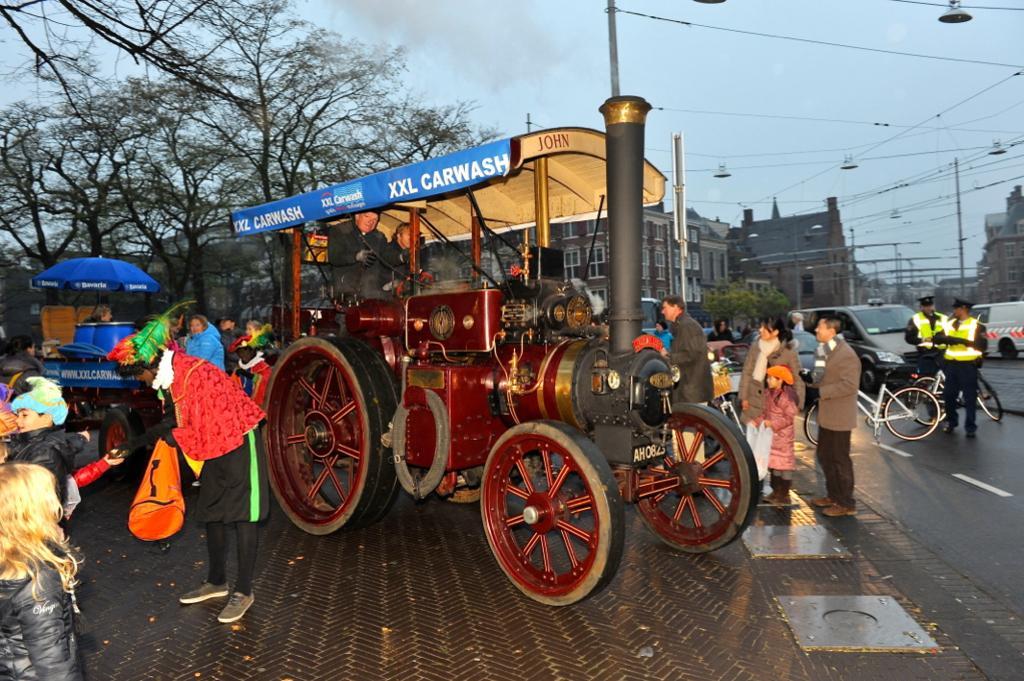In one or two sentences, can you explain what this image depicts? In the image there is a train and around that there are few people, on the right side there is a road and on the road there are some vehicles. in the background there are buildings and on the left side there are trees, there are many poles attached with wires around the road. 